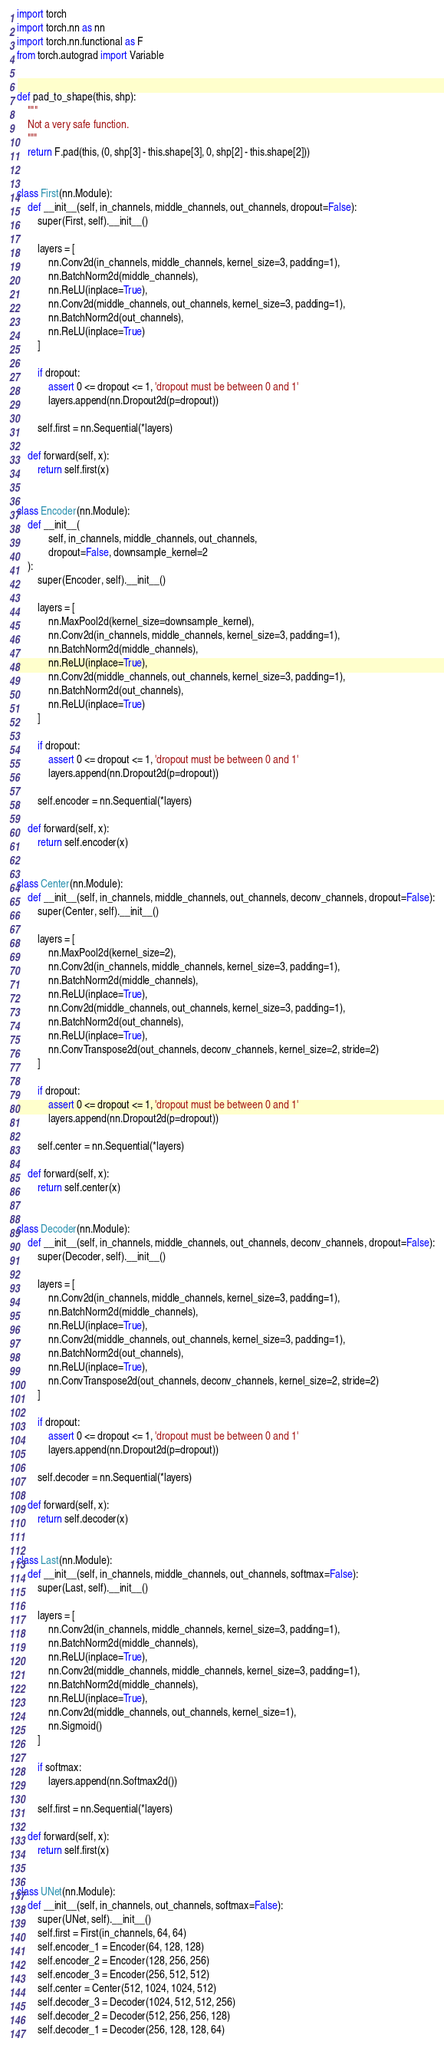Convert code to text. <code><loc_0><loc_0><loc_500><loc_500><_Python_>import torch
import torch.nn as nn
import torch.nn.functional as F
from torch.autograd import Variable


def pad_to_shape(this, shp):
    """
    Not a very safe function.
    """
    return F.pad(this, (0, shp[3] - this.shape[3], 0, shp[2] - this.shape[2]))


class First(nn.Module):
    def __init__(self, in_channels, middle_channels, out_channels, dropout=False):
        super(First, self).__init__()

        layers = [
            nn.Conv2d(in_channels, middle_channels, kernel_size=3, padding=1),
            nn.BatchNorm2d(middle_channels),
            nn.ReLU(inplace=True),
            nn.Conv2d(middle_channels, out_channels, kernel_size=3, padding=1),
            nn.BatchNorm2d(out_channels),
            nn.ReLU(inplace=True)
        ]

        if dropout:
            assert 0 <= dropout <= 1, 'dropout must be between 0 and 1'
            layers.append(nn.Dropout2d(p=dropout))

        self.first = nn.Sequential(*layers)

    def forward(self, x):
        return self.first(x)


class Encoder(nn.Module):
    def __init__(
            self, in_channels, middle_channels, out_channels,
            dropout=False, downsample_kernel=2
    ):
        super(Encoder, self).__init__()

        layers = [
            nn.MaxPool2d(kernel_size=downsample_kernel),
            nn.Conv2d(in_channels, middle_channels, kernel_size=3, padding=1),
            nn.BatchNorm2d(middle_channels),
            nn.ReLU(inplace=True),
            nn.Conv2d(middle_channels, out_channels, kernel_size=3, padding=1),
            nn.BatchNorm2d(out_channels),
            nn.ReLU(inplace=True)
        ]

        if dropout:
            assert 0 <= dropout <= 1, 'dropout must be between 0 and 1'
            layers.append(nn.Dropout2d(p=dropout))

        self.encoder = nn.Sequential(*layers)

    def forward(self, x):
        return self.encoder(x)


class Center(nn.Module):
    def __init__(self, in_channels, middle_channels, out_channels, deconv_channels, dropout=False):
        super(Center, self).__init__()

        layers = [
            nn.MaxPool2d(kernel_size=2),
            nn.Conv2d(in_channels, middle_channels, kernel_size=3, padding=1),
            nn.BatchNorm2d(middle_channels),
            nn.ReLU(inplace=True),
            nn.Conv2d(middle_channels, out_channels, kernel_size=3, padding=1),
            nn.BatchNorm2d(out_channels),
            nn.ReLU(inplace=True),
            nn.ConvTranspose2d(out_channels, deconv_channels, kernel_size=2, stride=2)
        ]

        if dropout:
            assert 0 <= dropout <= 1, 'dropout must be between 0 and 1'
            layers.append(nn.Dropout2d(p=dropout))

        self.center = nn.Sequential(*layers)

    def forward(self, x):
        return self.center(x)


class Decoder(nn.Module):
    def __init__(self, in_channels, middle_channels, out_channels, deconv_channels, dropout=False):
        super(Decoder, self).__init__()

        layers = [
            nn.Conv2d(in_channels, middle_channels, kernel_size=3, padding=1),
            nn.BatchNorm2d(middle_channels),
            nn.ReLU(inplace=True),
            nn.Conv2d(middle_channels, out_channels, kernel_size=3, padding=1),
            nn.BatchNorm2d(out_channels),
            nn.ReLU(inplace=True),
            nn.ConvTranspose2d(out_channels, deconv_channels, kernel_size=2, stride=2)
        ]

        if dropout:
            assert 0 <= dropout <= 1, 'dropout must be between 0 and 1'
            layers.append(nn.Dropout2d(p=dropout))

        self.decoder = nn.Sequential(*layers)

    def forward(self, x):
        return self.decoder(x)


class Last(nn.Module):
    def __init__(self, in_channels, middle_channels, out_channels, softmax=False):
        super(Last, self).__init__()

        layers = [
            nn.Conv2d(in_channels, middle_channels, kernel_size=3, padding=1),
            nn.BatchNorm2d(middle_channels),
            nn.ReLU(inplace=True),
            nn.Conv2d(middle_channels, middle_channels, kernel_size=3, padding=1),
            nn.BatchNorm2d(middle_channels),
            nn.ReLU(inplace=True),
            nn.Conv2d(middle_channels, out_channels, kernel_size=1),
            nn.Sigmoid()
        ]

        if softmax:
            layers.append(nn.Softmax2d())

        self.first = nn.Sequential(*layers)

    def forward(self, x):
        return self.first(x)


class UNet(nn.Module):
    def __init__(self, in_channels, out_channels, softmax=False):
        super(UNet, self).__init__()
        self.first = First(in_channels, 64, 64)
        self.encoder_1 = Encoder(64, 128, 128)
        self.encoder_2 = Encoder(128, 256, 256)
        self.encoder_3 = Encoder(256, 512, 512)
        self.center = Center(512, 1024, 1024, 512)
        self.decoder_3 = Decoder(1024, 512, 512, 256)
        self.decoder_2 = Decoder(512, 256, 256, 128)
        self.decoder_1 = Decoder(256, 128, 128, 64)</code> 